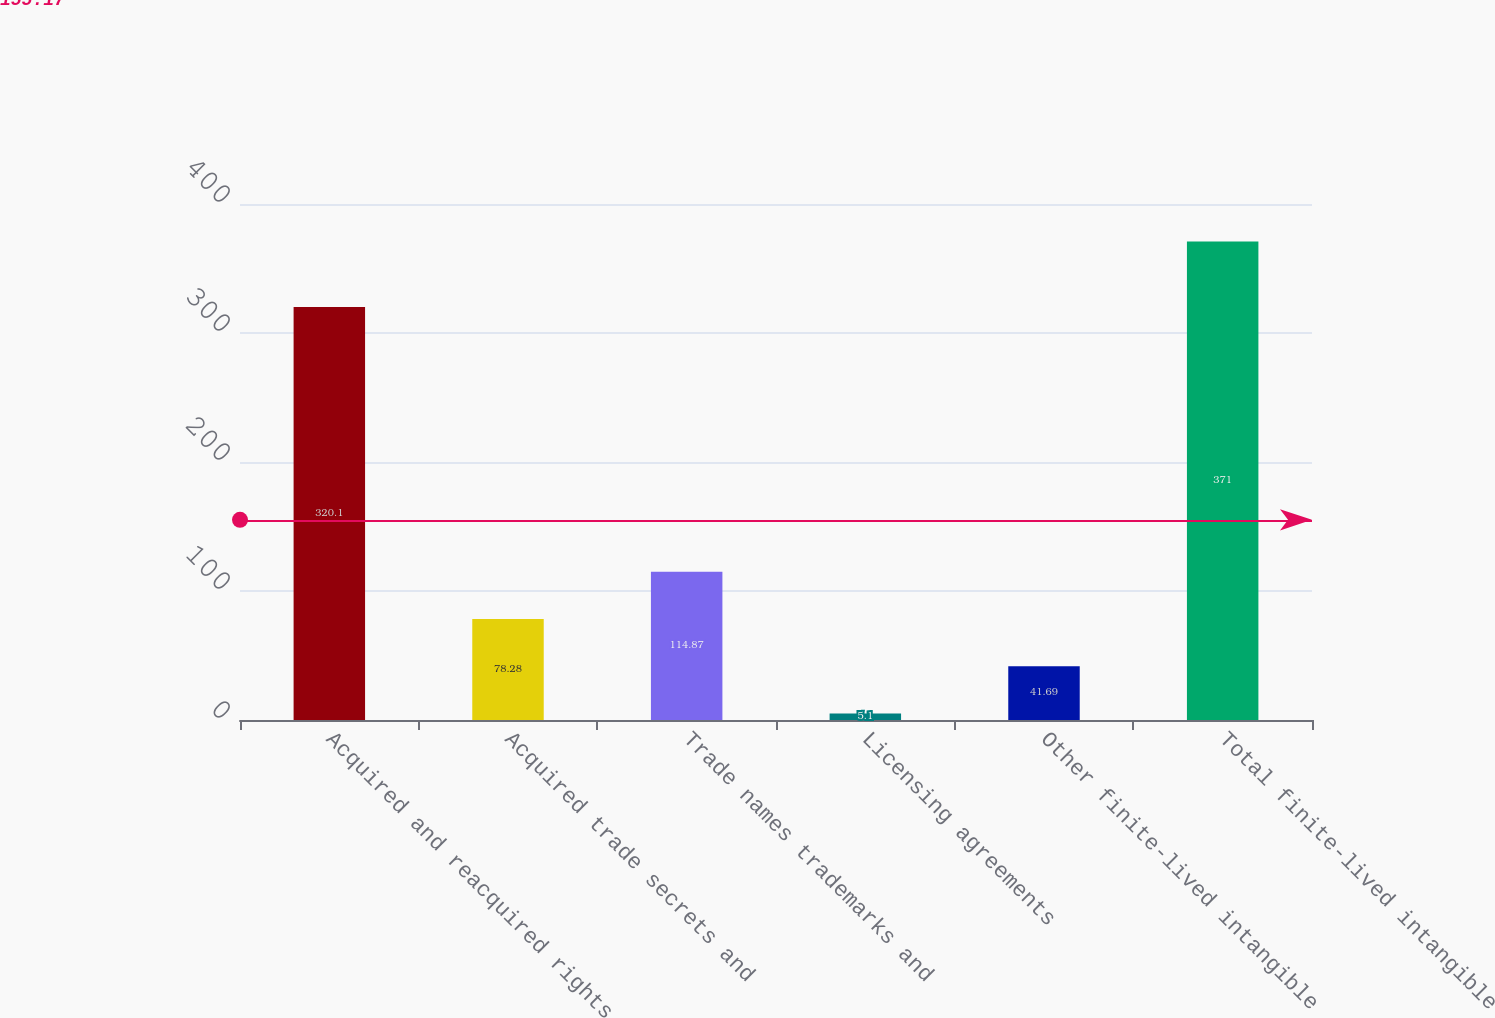Convert chart to OTSL. <chart><loc_0><loc_0><loc_500><loc_500><bar_chart><fcel>Acquired and reacquired rights<fcel>Acquired trade secrets and<fcel>Trade names trademarks and<fcel>Licensing agreements<fcel>Other finite-lived intangible<fcel>Total finite-lived intangible<nl><fcel>320.1<fcel>78.28<fcel>114.87<fcel>5.1<fcel>41.69<fcel>371<nl></chart> 